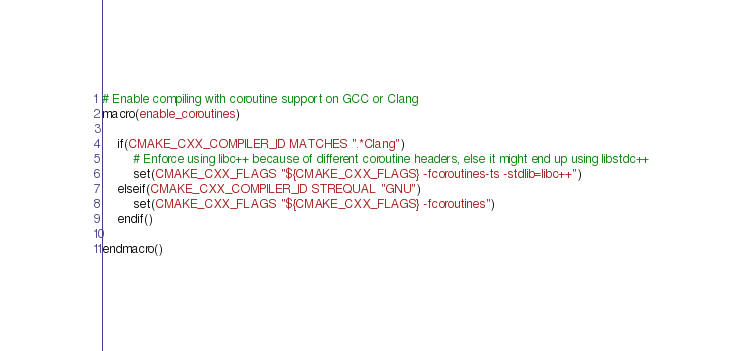Convert code to text. <code><loc_0><loc_0><loc_500><loc_500><_CMake_># Enable compiling with coroutine support on GCC or Clang
macro(enable_coroutines)

    if(CMAKE_CXX_COMPILER_ID MATCHES ".*Clang")
        # Enforce using libc++ because of different coroutine headers, else it might end up using libstdc++
        set(CMAKE_CXX_FLAGS "${CMAKE_CXX_FLAGS} -fcoroutines-ts -stdlib=libc++")
    elseif(CMAKE_CXX_COMPILER_ID STREQUAL "GNU")
        set(CMAKE_CXX_FLAGS "${CMAKE_CXX_FLAGS} -fcoroutines")
    endif()

endmacro()
</code> 